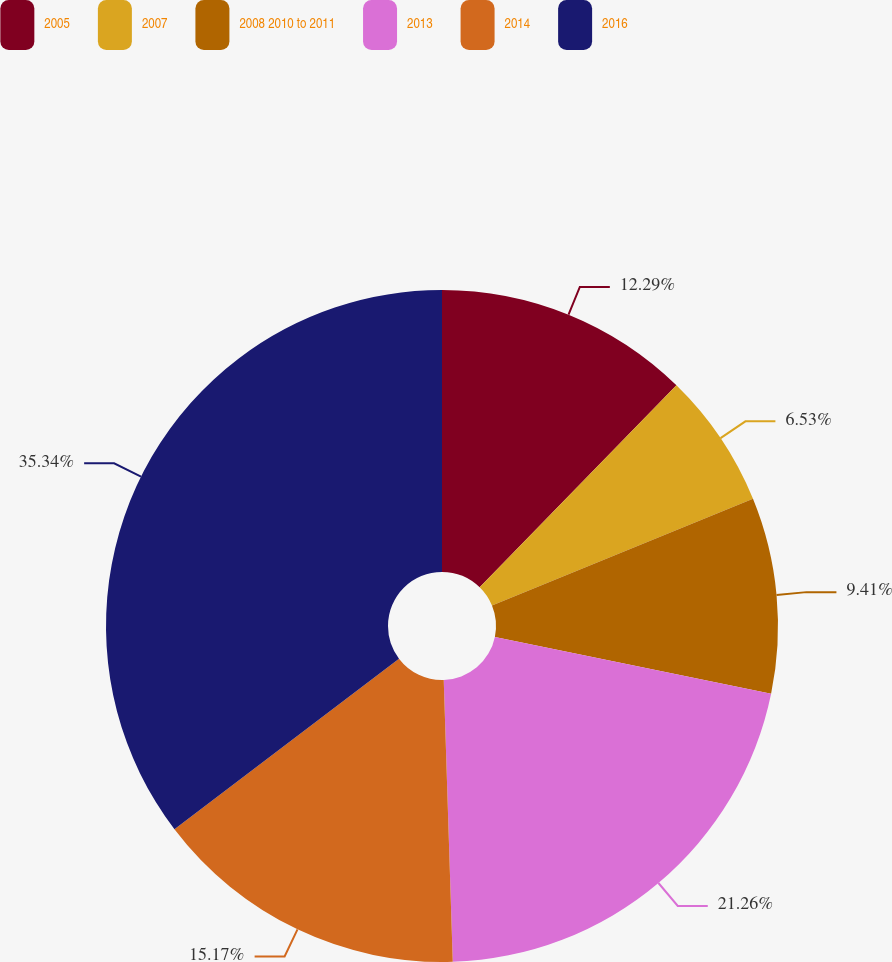<chart> <loc_0><loc_0><loc_500><loc_500><pie_chart><fcel>2005<fcel>2007<fcel>2008 2010 to 2011<fcel>2013<fcel>2014<fcel>2016<nl><fcel>12.29%<fcel>6.53%<fcel>9.41%<fcel>21.26%<fcel>15.17%<fcel>35.34%<nl></chart> 